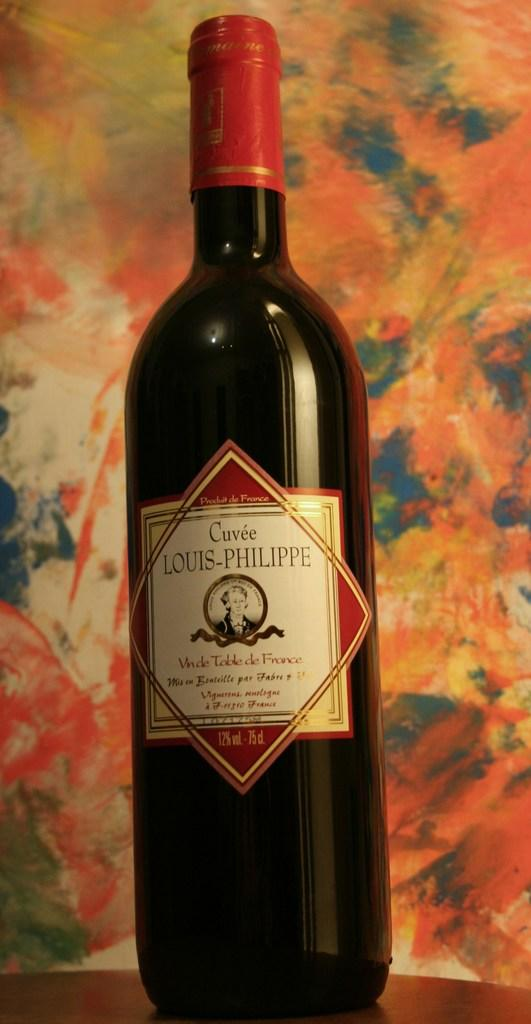Provide a one-sentence caption for the provided image. A Cuvee Louis-Philippe wine is sitting on a brown table with a colorful background. 